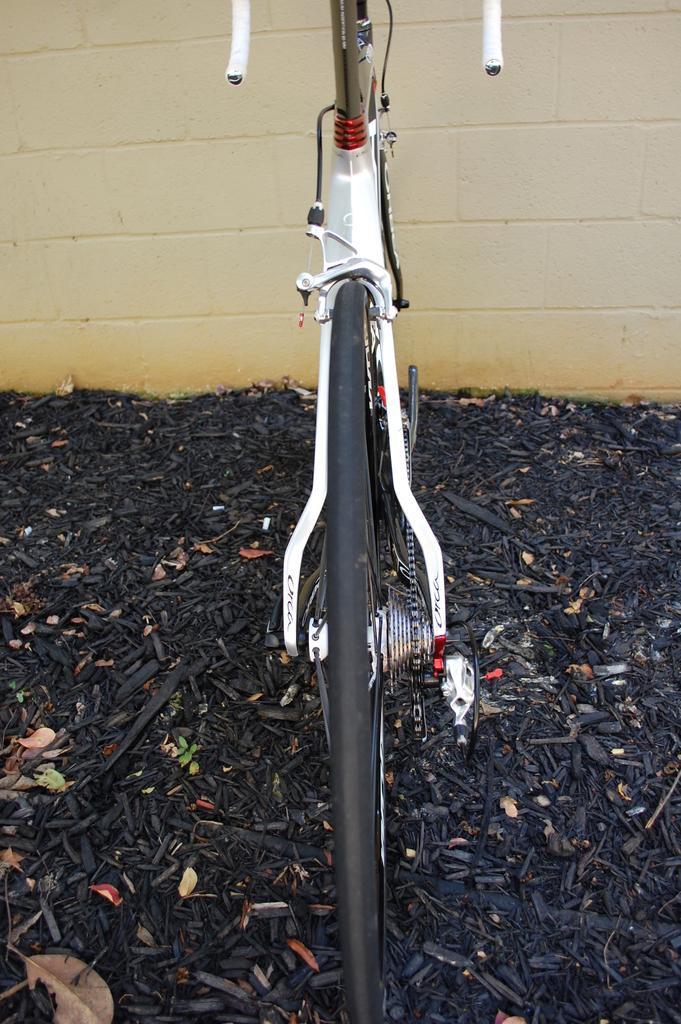How would you summarize this image in a sentence or two? In the picture we can see a bicycle which is parked on the dried twigs surface which is black in color and in the background we can see a wall which is cream in color. 